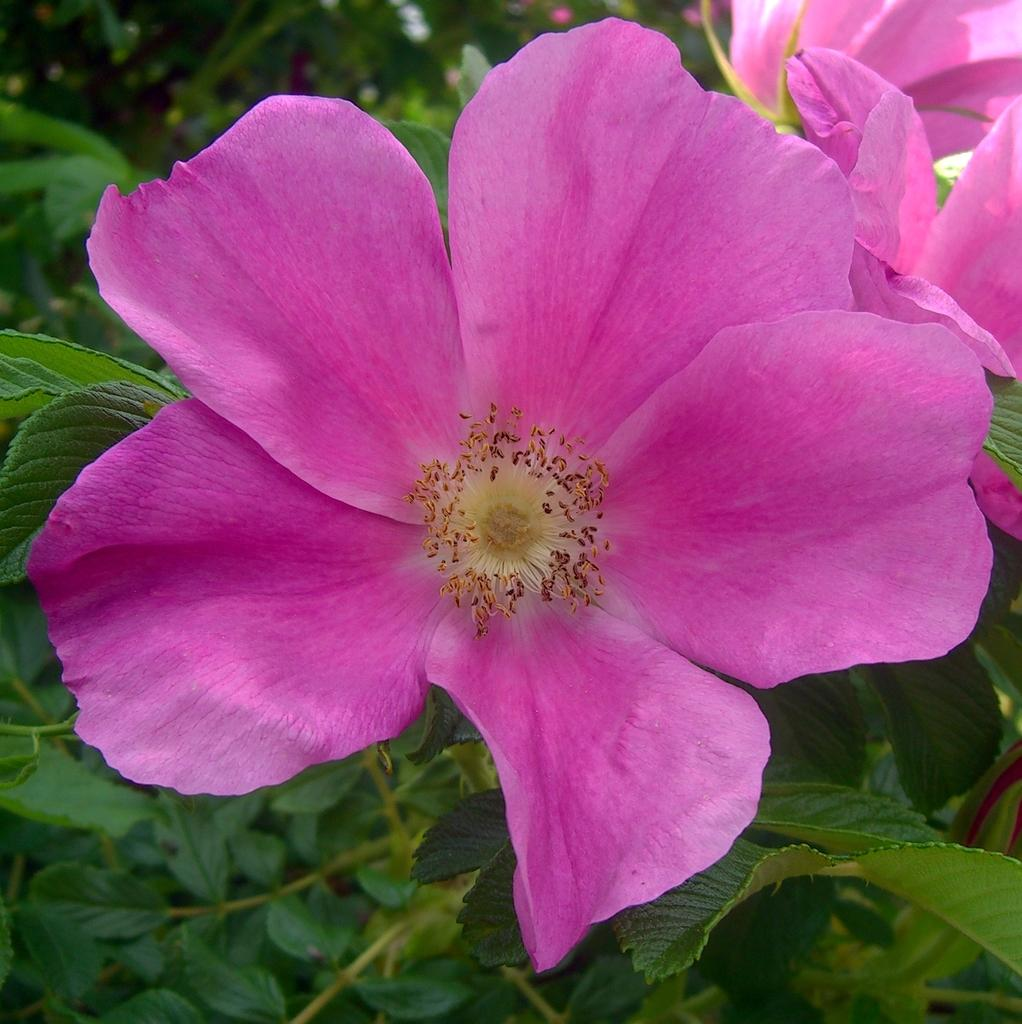What type of flowers can be seen on the plant in the image? There are pink flowers on the plant in the image. Can you describe the color of the flowers? The flowers are pink. What is the main subject of the image? The main subject of the image is a plant with pink flowers. How many hands are visible in the image? There are no hands visible in the image; it only features a plant with pink flowers. 